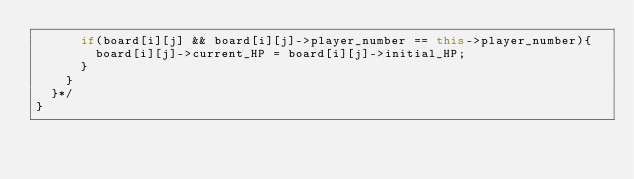<code> <loc_0><loc_0><loc_500><loc_500><_C++_>			if(board[i][j] && board[i][j]->player_number == this->player_number){
				board[i][j]->current_HP = board[i][j]->initial_HP;
			}
		}
	}*/
}

</code> 